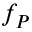Convert formula to latex. <formula><loc_0><loc_0><loc_500><loc_500>f _ { P }</formula> 